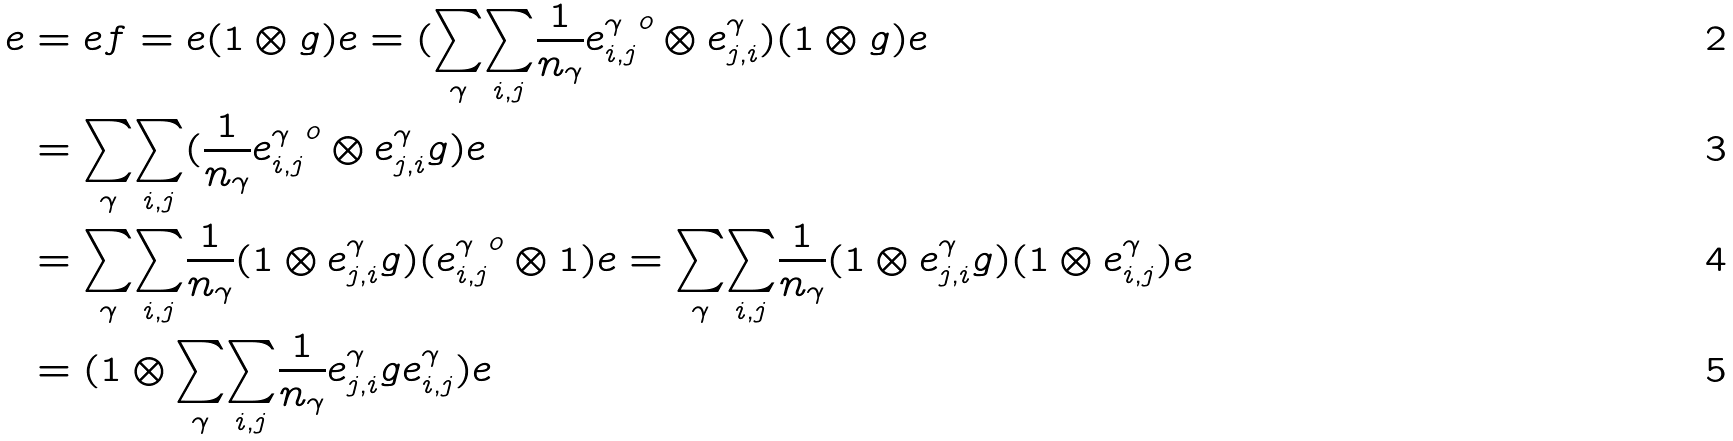<formula> <loc_0><loc_0><loc_500><loc_500>e & = e f = e ( 1 \otimes g ) e = ( \underset { \gamma } { \sum } \underset { i , j } \sum \frac { 1 } { n _ { \gamma } } { e ^ { \gamma } _ { i , j } } ^ { o } \otimes e ^ { \gamma } _ { j , i } ) ( 1 \otimes g ) e \\ & = \underset { \gamma } { \sum } \underset { i , j } \sum ( \frac { 1 } { n _ { \gamma } } { e ^ { \gamma } _ { i , j } } ^ { o } \otimes e ^ { \gamma } _ { j , i } g ) e \\ & = \underset { \gamma } { \sum } \underset { i , j } \sum \frac { 1 } { n _ { \gamma } } ( 1 \otimes e ^ { \gamma } _ { j , i } g ) ( { e ^ { \gamma } _ { i , j } } ^ { o } \otimes 1 ) e = \underset { \gamma } { \sum } \underset { i , j } \sum \frac { 1 } { n _ { \gamma } } ( 1 \otimes e ^ { \gamma } _ { j , i } g ) ( 1 \otimes e ^ { \gamma } _ { i , j } ) e \\ & = ( 1 \otimes \underset { \gamma } { \sum } \underset { i , j } \sum \frac { 1 } { n _ { \gamma } } e ^ { \gamma } _ { j , i } g e ^ { \gamma } _ { i , j } ) e</formula> 